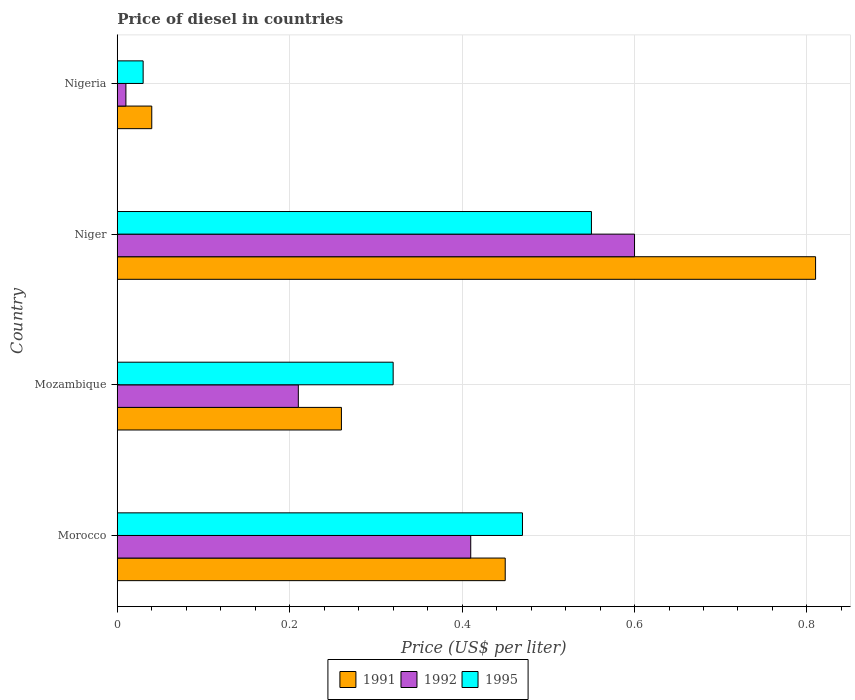How many different coloured bars are there?
Ensure brevity in your answer.  3. How many bars are there on the 3rd tick from the bottom?
Provide a succinct answer. 3. What is the label of the 1st group of bars from the top?
Your answer should be very brief. Nigeria. Across all countries, what is the maximum price of diesel in 1995?
Make the answer very short. 0.55. In which country was the price of diesel in 1995 maximum?
Ensure brevity in your answer.  Niger. In which country was the price of diesel in 1991 minimum?
Make the answer very short. Nigeria. What is the total price of diesel in 1991 in the graph?
Provide a short and direct response. 1.56. What is the difference between the price of diesel in 1992 in Mozambique and that in Niger?
Ensure brevity in your answer.  -0.39. What is the difference between the price of diesel in 1995 in Mozambique and the price of diesel in 1992 in Nigeria?
Make the answer very short. 0.31. What is the average price of diesel in 1992 per country?
Your answer should be very brief. 0.31. What is the ratio of the price of diesel in 1995 in Morocco to that in Nigeria?
Your answer should be compact. 15.67. What is the difference between the highest and the second highest price of diesel in 1992?
Offer a very short reply. 0.19. What is the difference between the highest and the lowest price of diesel in 1992?
Ensure brevity in your answer.  0.59. In how many countries, is the price of diesel in 1992 greater than the average price of diesel in 1992 taken over all countries?
Ensure brevity in your answer.  2. Is the sum of the price of diesel in 1995 in Morocco and Mozambique greater than the maximum price of diesel in 1991 across all countries?
Your answer should be very brief. No. What does the 3rd bar from the bottom in Mozambique represents?
Ensure brevity in your answer.  1995. Is it the case that in every country, the sum of the price of diesel in 1995 and price of diesel in 1992 is greater than the price of diesel in 1991?
Ensure brevity in your answer.  No. How many bars are there?
Make the answer very short. 12. Does the graph contain any zero values?
Give a very brief answer. No. Where does the legend appear in the graph?
Provide a succinct answer. Bottom center. How many legend labels are there?
Your answer should be very brief. 3. How are the legend labels stacked?
Keep it short and to the point. Horizontal. What is the title of the graph?
Provide a succinct answer. Price of diesel in countries. Does "1991" appear as one of the legend labels in the graph?
Your answer should be very brief. Yes. What is the label or title of the X-axis?
Your answer should be compact. Price (US$ per liter). What is the label or title of the Y-axis?
Provide a short and direct response. Country. What is the Price (US$ per liter) of 1991 in Morocco?
Your answer should be very brief. 0.45. What is the Price (US$ per liter) in 1992 in Morocco?
Provide a succinct answer. 0.41. What is the Price (US$ per liter) in 1995 in Morocco?
Your answer should be very brief. 0.47. What is the Price (US$ per liter) in 1991 in Mozambique?
Make the answer very short. 0.26. What is the Price (US$ per liter) in 1992 in Mozambique?
Keep it short and to the point. 0.21. What is the Price (US$ per liter) of 1995 in Mozambique?
Your answer should be compact. 0.32. What is the Price (US$ per liter) of 1991 in Niger?
Keep it short and to the point. 0.81. What is the Price (US$ per liter) of 1995 in Niger?
Your response must be concise. 0.55. What is the Price (US$ per liter) of 1992 in Nigeria?
Ensure brevity in your answer.  0.01. What is the Price (US$ per liter) of 1995 in Nigeria?
Offer a very short reply. 0.03. Across all countries, what is the maximum Price (US$ per liter) of 1991?
Make the answer very short. 0.81. Across all countries, what is the maximum Price (US$ per liter) of 1992?
Provide a succinct answer. 0.6. Across all countries, what is the maximum Price (US$ per liter) in 1995?
Your answer should be compact. 0.55. Across all countries, what is the minimum Price (US$ per liter) of 1991?
Provide a succinct answer. 0.04. Across all countries, what is the minimum Price (US$ per liter) of 1992?
Your answer should be very brief. 0.01. Across all countries, what is the minimum Price (US$ per liter) in 1995?
Give a very brief answer. 0.03. What is the total Price (US$ per liter) of 1991 in the graph?
Provide a short and direct response. 1.56. What is the total Price (US$ per liter) in 1992 in the graph?
Offer a terse response. 1.23. What is the total Price (US$ per liter) of 1995 in the graph?
Give a very brief answer. 1.37. What is the difference between the Price (US$ per liter) in 1991 in Morocco and that in Mozambique?
Offer a terse response. 0.19. What is the difference between the Price (US$ per liter) in 1992 in Morocco and that in Mozambique?
Your response must be concise. 0.2. What is the difference between the Price (US$ per liter) of 1991 in Morocco and that in Niger?
Offer a very short reply. -0.36. What is the difference between the Price (US$ per liter) in 1992 in Morocco and that in Niger?
Your answer should be compact. -0.19. What is the difference between the Price (US$ per liter) of 1995 in Morocco and that in Niger?
Offer a terse response. -0.08. What is the difference between the Price (US$ per liter) of 1991 in Morocco and that in Nigeria?
Keep it short and to the point. 0.41. What is the difference between the Price (US$ per liter) in 1995 in Morocco and that in Nigeria?
Your answer should be very brief. 0.44. What is the difference between the Price (US$ per liter) in 1991 in Mozambique and that in Niger?
Provide a succinct answer. -0.55. What is the difference between the Price (US$ per liter) of 1992 in Mozambique and that in Niger?
Offer a very short reply. -0.39. What is the difference between the Price (US$ per liter) in 1995 in Mozambique and that in Niger?
Keep it short and to the point. -0.23. What is the difference between the Price (US$ per liter) in 1991 in Mozambique and that in Nigeria?
Offer a terse response. 0.22. What is the difference between the Price (US$ per liter) in 1995 in Mozambique and that in Nigeria?
Offer a very short reply. 0.29. What is the difference between the Price (US$ per liter) of 1991 in Niger and that in Nigeria?
Your answer should be very brief. 0.77. What is the difference between the Price (US$ per liter) of 1992 in Niger and that in Nigeria?
Your answer should be very brief. 0.59. What is the difference between the Price (US$ per liter) of 1995 in Niger and that in Nigeria?
Your response must be concise. 0.52. What is the difference between the Price (US$ per liter) in 1991 in Morocco and the Price (US$ per liter) in 1992 in Mozambique?
Provide a short and direct response. 0.24. What is the difference between the Price (US$ per liter) of 1991 in Morocco and the Price (US$ per liter) of 1995 in Mozambique?
Keep it short and to the point. 0.13. What is the difference between the Price (US$ per liter) in 1992 in Morocco and the Price (US$ per liter) in 1995 in Mozambique?
Provide a short and direct response. 0.09. What is the difference between the Price (US$ per liter) in 1991 in Morocco and the Price (US$ per liter) in 1995 in Niger?
Provide a succinct answer. -0.1. What is the difference between the Price (US$ per liter) in 1992 in Morocco and the Price (US$ per liter) in 1995 in Niger?
Make the answer very short. -0.14. What is the difference between the Price (US$ per liter) in 1991 in Morocco and the Price (US$ per liter) in 1992 in Nigeria?
Ensure brevity in your answer.  0.44. What is the difference between the Price (US$ per liter) in 1991 in Morocco and the Price (US$ per liter) in 1995 in Nigeria?
Provide a succinct answer. 0.42. What is the difference between the Price (US$ per liter) in 1992 in Morocco and the Price (US$ per liter) in 1995 in Nigeria?
Your answer should be very brief. 0.38. What is the difference between the Price (US$ per liter) in 1991 in Mozambique and the Price (US$ per liter) in 1992 in Niger?
Your answer should be very brief. -0.34. What is the difference between the Price (US$ per liter) of 1991 in Mozambique and the Price (US$ per liter) of 1995 in Niger?
Offer a terse response. -0.29. What is the difference between the Price (US$ per liter) of 1992 in Mozambique and the Price (US$ per liter) of 1995 in Niger?
Provide a short and direct response. -0.34. What is the difference between the Price (US$ per liter) in 1991 in Mozambique and the Price (US$ per liter) in 1992 in Nigeria?
Offer a very short reply. 0.25. What is the difference between the Price (US$ per liter) of 1991 in Mozambique and the Price (US$ per liter) of 1995 in Nigeria?
Give a very brief answer. 0.23. What is the difference between the Price (US$ per liter) of 1992 in Mozambique and the Price (US$ per liter) of 1995 in Nigeria?
Keep it short and to the point. 0.18. What is the difference between the Price (US$ per liter) of 1991 in Niger and the Price (US$ per liter) of 1995 in Nigeria?
Give a very brief answer. 0.78. What is the difference between the Price (US$ per liter) of 1992 in Niger and the Price (US$ per liter) of 1995 in Nigeria?
Provide a succinct answer. 0.57. What is the average Price (US$ per liter) in 1991 per country?
Your answer should be compact. 0.39. What is the average Price (US$ per liter) in 1992 per country?
Ensure brevity in your answer.  0.31. What is the average Price (US$ per liter) in 1995 per country?
Your answer should be compact. 0.34. What is the difference between the Price (US$ per liter) in 1991 and Price (US$ per liter) in 1992 in Morocco?
Provide a succinct answer. 0.04. What is the difference between the Price (US$ per liter) in 1991 and Price (US$ per liter) in 1995 in Morocco?
Your answer should be compact. -0.02. What is the difference between the Price (US$ per liter) of 1992 and Price (US$ per liter) of 1995 in Morocco?
Provide a succinct answer. -0.06. What is the difference between the Price (US$ per liter) of 1991 and Price (US$ per liter) of 1995 in Mozambique?
Provide a short and direct response. -0.06. What is the difference between the Price (US$ per liter) in 1992 and Price (US$ per liter) in 1995 in Mozambique?
Your answer should be compact. -0.11. What is the difference between the Price (US$ per liter) in 1991 and Price (US$ per liter) in 1992 in Niger?
Give a very brief answer. 0.21. What is the difference between the Price (US$ per liter) in 1991 and Price (US$ per liter) in 1995 in Niger?
Ensure brevity in your answer.  0.26. What is the difference between the Price (US$ per liter) of 1992 and Price (US$ per liter) of 1995 in Niger?
Provide a succinct answer. 0.05. What is the difference between the Price (US$ per liter) in 1992 and Price (US$ per liter) in 1995 in Nigeria?
Your response must be concise. -0.02. What is the ratio of the Price (US$ per liter) of 1991 in Morocco to that in Mozambique?
Provide a succinct answer. 1.73. What is the ratio of the Price (US$ per liter) of 1992 in Morocco to that in Mozambique?
Your answer should be very brief. 1.95. What is the ratio of the Price (US$ per liter) of 1995 in Morocco to that in Mozambique?
Your response must be concise. 1.47. What is the ratio of the Price (US$ per liter) in 1991 in Morocco to that in Niger?
Provide a succinct answer. 0.56. What is the ratio of the Price (US$ per liter) in 1992 in Morocco to that in Niger?
Ensure brevity in your answer.  0.68. What is the ratio of the Price (US$ per liter) of 1995 in Morocco to that in Niger?
Your answer should be compact. 0.85. What is the ratio of the Price (US$ per liter) of 1991 in Morocco to that in Nigeria?
Keep it short and to the point. 11.25. What is the ratio of the Price (US$ per liter) of 1992 in Morocco to that in Nigeria?
Make the answer very short. 41. What is the ratio of the Price (US$ per liter) of 1995 in Morocco to that in Nigeria?
Give a very brief answer. 15.67. What is the ratio of the Price (US$ per liter) in 1991 in Mozambique to that in Niger?
Give a very brief answer. 0.32. What is the ratio of the Price (US$ per liter) of 1995 in Mozambique to that in Niger?
Keep it short and to the point. 0.58. What is the ratio of the Price (US$ per liter) in 1991 in Mozambique to that in Nigeria?
Make the answer very short. 6.5. What is the ratio of the Price (US$ per liter) of 1995 in Mozambique to that in Nigeria?
Your response must be concise. 10.67. What is the ratio of the Price (US$ per liter) in 1991 in Niger to that in Nigeria?
Keep it short and to the point. 20.25. What is the ratio of the Price (US$ per liter) of 1995 in Niger to that in Nigeria?
Make the answer very short. 18.33. What is the difference between the highest and the second highest Price (US$ per liter) of 1991?
Offer a terse response. 0.36. What is the difference between the highest and the second highest Price (US$ per liter) in 1992?
Make the answer very short. 0.19. What is the difference between the highest and the second highest Price (US$ per liter) in 1995?
Give a very brief answer. 0.08. What is the difference between the highest and the lowest Price (US$ per liter) in 1991?
Make the answer very short. 0.77. What is the difference between the highest and the lowest Price (US$ per liter) of 1992?
Ensure brevity in your answer.  0.59. What is the difference between the highest and the lowest Price (US$ per liter) in 1995?
Your answer should be compact. 0.52. 